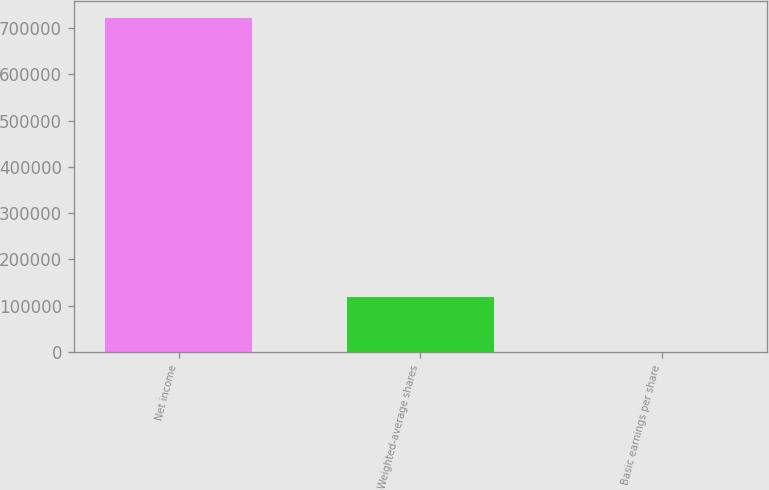<chart> <loc_0><loc_0><loc_500><loc_500><bar_chart><fcel>Net income<fcel>Weighted-average shares<fcel>Basic earnings per share<nl><fcel>722521<fcel>117696<fcel>6.14<nl></chart> 